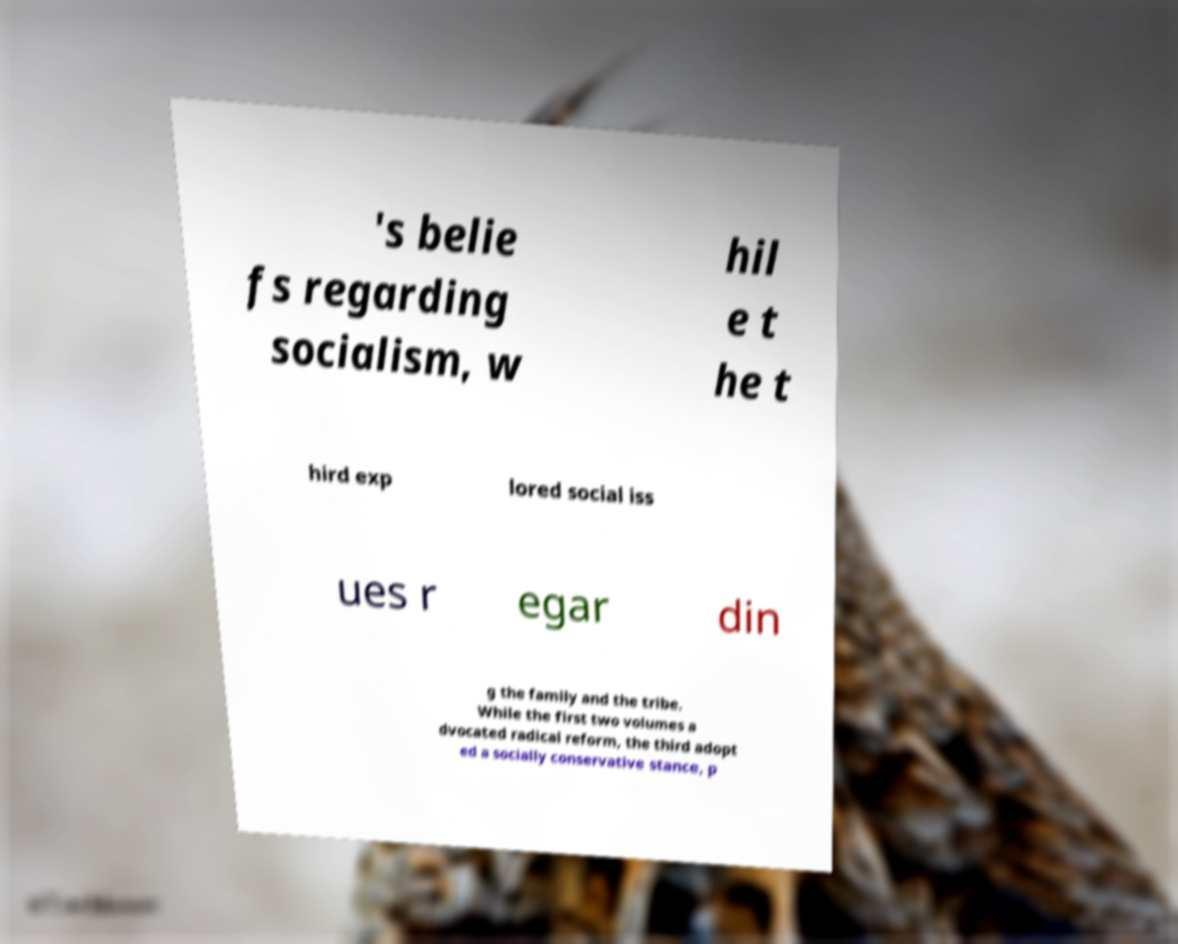I need the written content from this picture converted into text. Can you do that? 's belie fs regarding socialism, w hil e t he t hird exp lored social iss ues r egar din g the family and the tribe. While the first two volumes a dvocated radical reform, the third adopt ed a socially conservative stance, p 